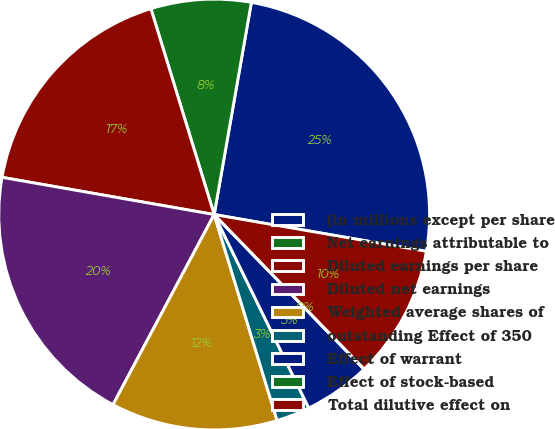Convert chart. <chart><loc_0><loc_0><loc_500><loc_500><pie_chart><fcel>(in millions except per share<fcel>Net earnings attributable to<fcel>Diluted earnings per share<fcel>Diluted net earnings<fcel>Weighted average shares of<fcel>outstanding Effect of 350<fcel>Effect of warrant<fcel>Effect of stock-based<fcel>Total dilutive effect on<nl><fcel>24.97%<fcel>7.51%<fcel>17.49%<fcel>19.98%<fcel>12.5%<fcel>2.52%<fcel>5.01%<fcel>0.02%<fcel>10.0%<nl></chart> 